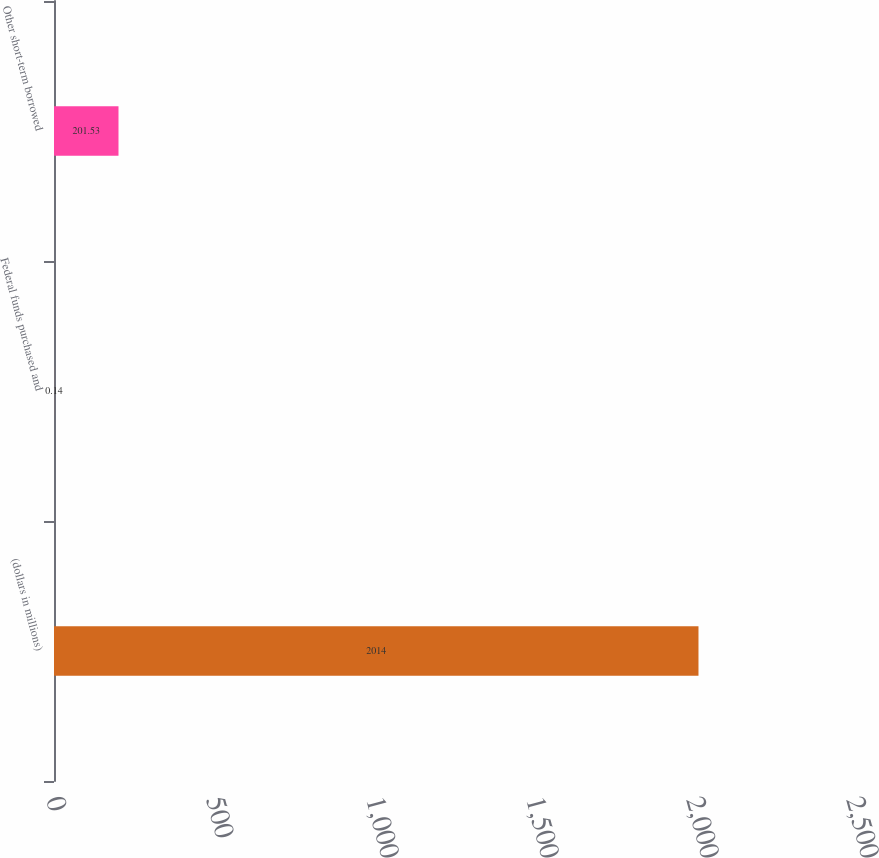Convert chart. <chart><loc_0><loc_0><loc_500><loc_500><bar_chart><fcel>(dollars in millions)<fcel>Federal funds purchased and<fcel>Other short-term borrowed<nl><fcel>2014<fcel>0.14<fcel>201.53<nl></chart> 